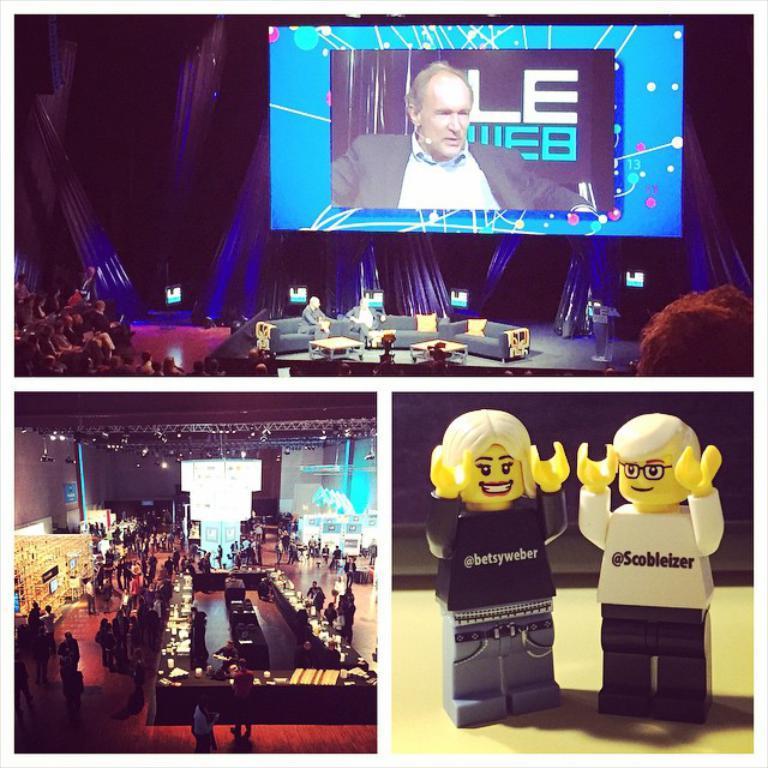How would you summarize this image in a sentence or two? There is a collage image of three different pictures. In the first picture we can see a person on the screen. In the second picture, we can see a table and some persons. In the third picture, we can see toys. 